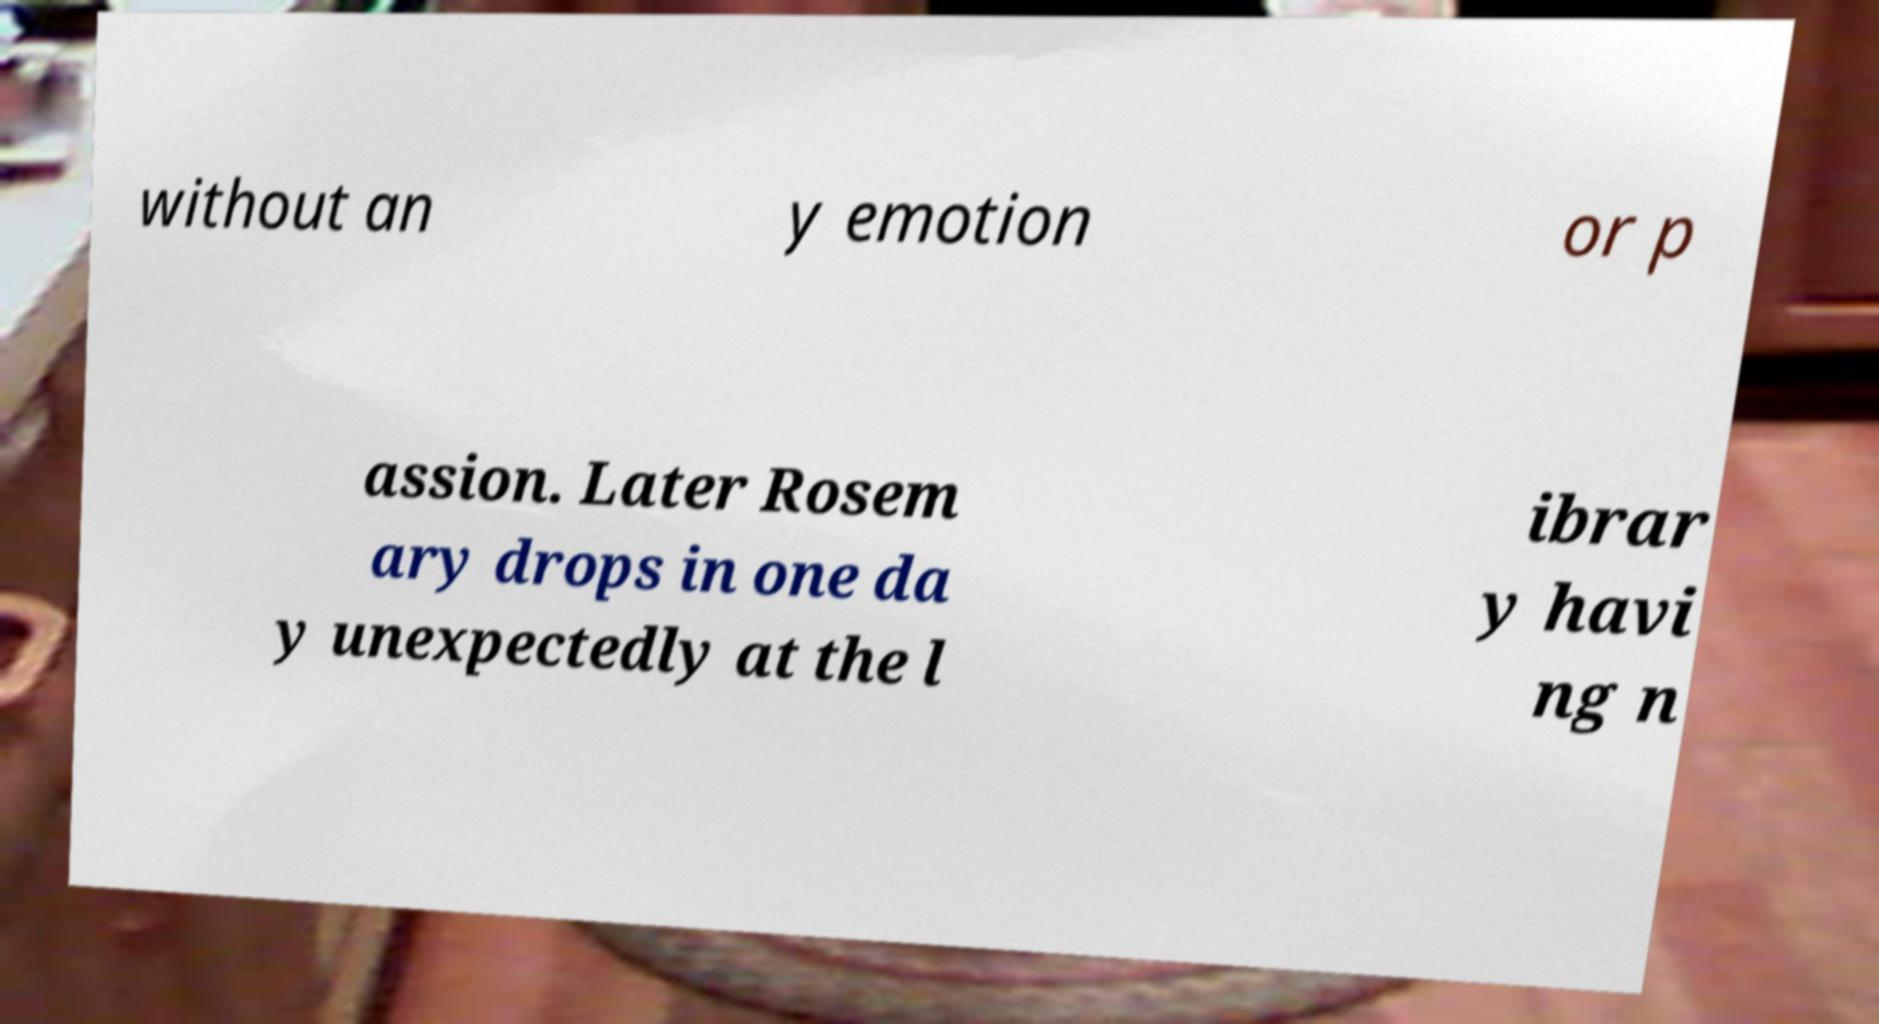Please read and relay the text visible in this image. What does it say? without an y emotion or p assion. Later Rosem ary drops in one da y unexpectedly at the l ibrar y havi ng n 